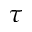Convert formula to latex. <formula><loc_0><loc_0><loc_500><loc_500>\tau</formula> 